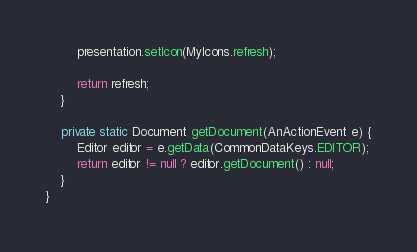<code> <loc_0><loc_0><loc_500><loc_500><_Java_>		presentation.setIcon(MyIcons.refresh);

		return refresh;
	}

	private static Document getDocument(AnActionEvent e) {
		Editor editor = e.getData(CommonDataKeys.EDITOR);
		return editor != null ? editor.getDocument() : null;
	}
}
</code> 